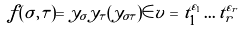Convert formula to latex. <formula><loc_0><loc_0><loc_500><loc_500>f ( \sigma , \tau ) = y _ { \sigma } y _ { \tau } ( y _ { \sigma \tau } ) \in v = t _ { 1 } ^ { \varepsilon _ { 1 } } \dots t _ { r } ^ { \varepsilon _ { r } }</formula> 